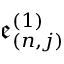Convert formula to latex. <formula><loc_0><loc_0><loc_500><loc_500>\mathfrak { e } _ { ( n , j ) } ^ { ( 1 ) }</formula> 